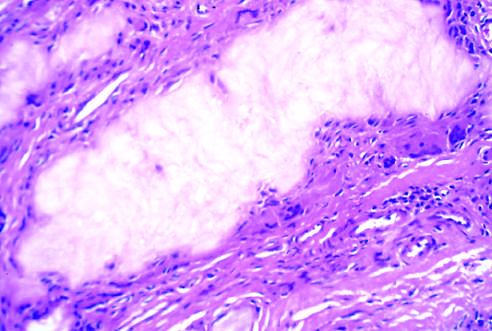what is surrounded by reactive fibroblasts, mononuclear inflammatory cells, and giant cells?
Answer the question using a single word or phrase. An aggregate of dissolved urate crystals cells 